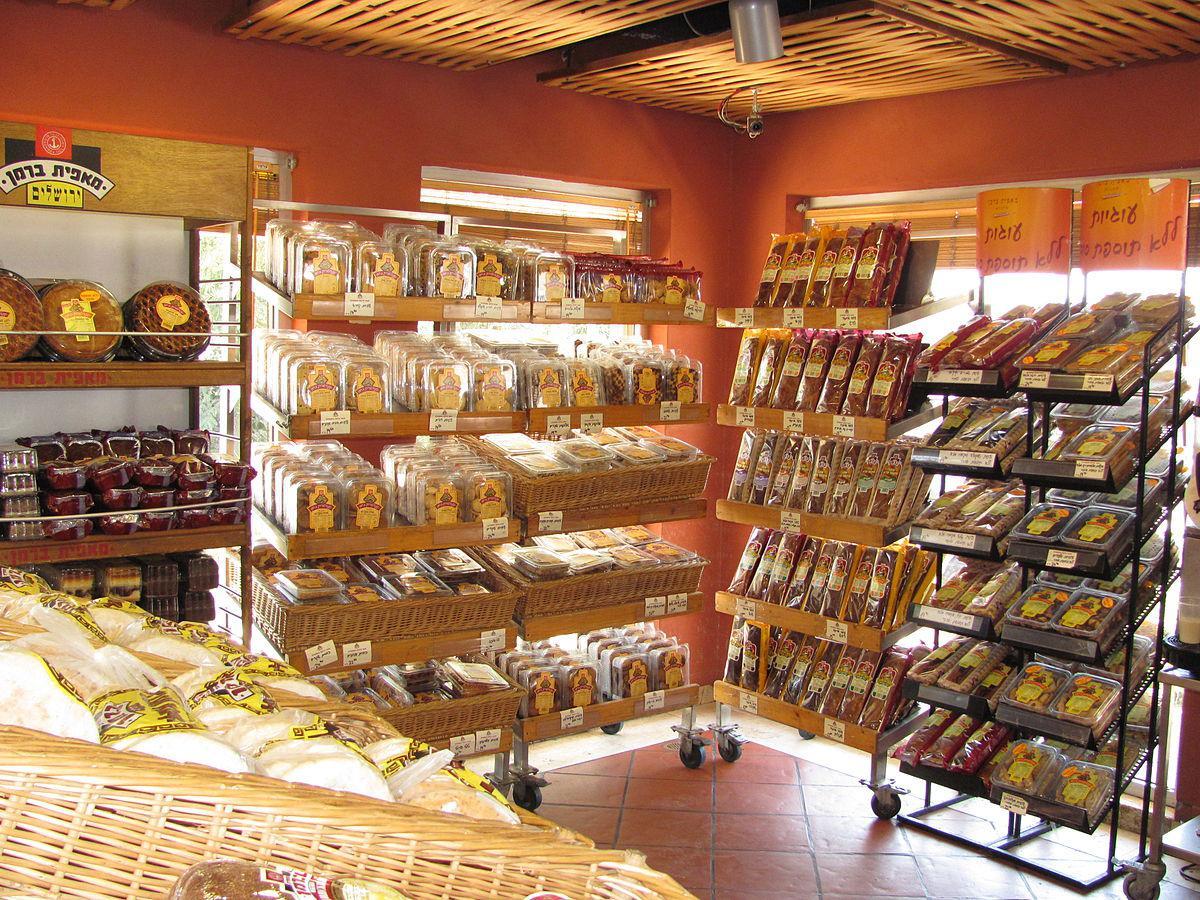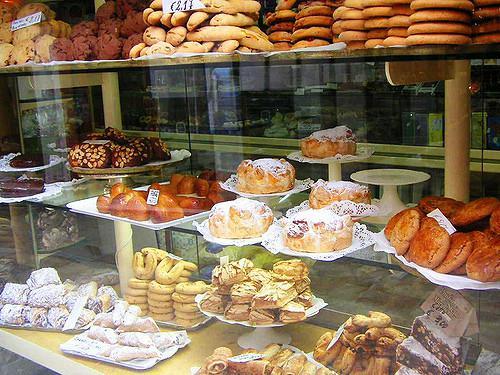The first image is the image on the left, the second image is the image on the right. Assess this claim about the two images: "There is a shoppe entrance with a striped awning.". Correct or not? Answer yes or no. No. The first image is the image on the left, the second image is the image on the right. Examine the images to the left and right. Is the description "The shop door is at least partially visible in the iamge on the right" accurate? Answer yes or no. No. 